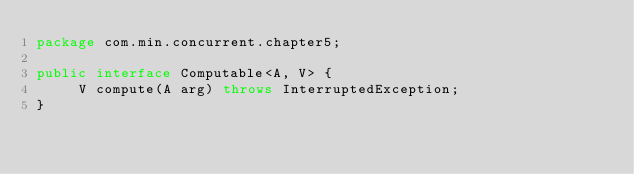Convert code to text. <code><loc_0><loc_0><loc_500><loc_500><_Java_>package com.min.concurrent.chapter5;

public interface Computable<A, V> {
	 V compute(A arg) throws InterruptedException;
}
</code> 